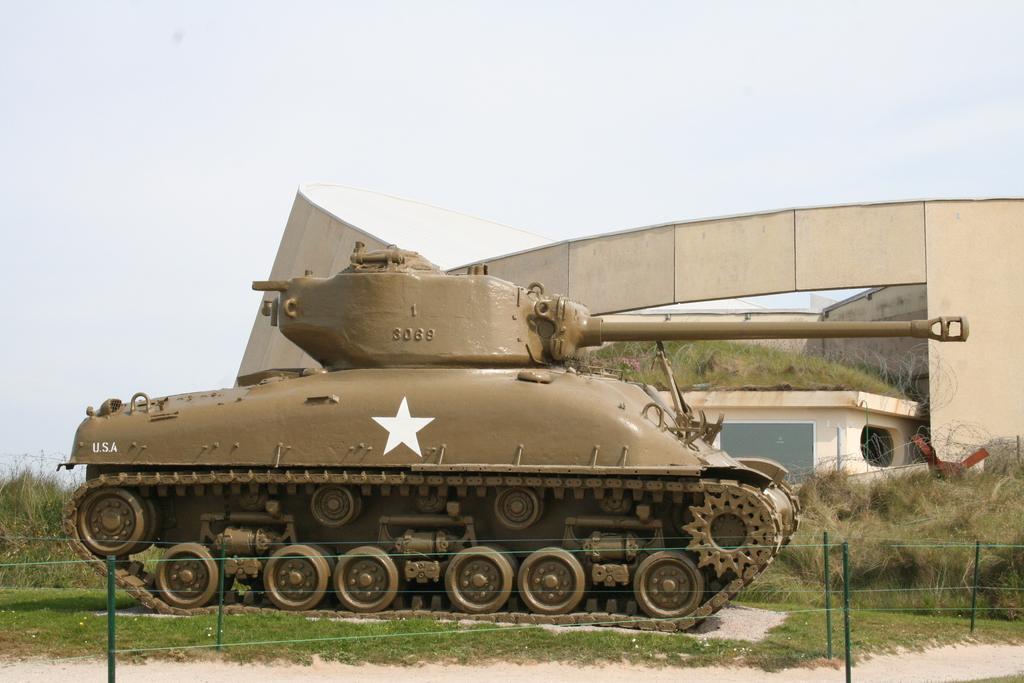What is the main object on the surface in the image? There is a tank on the surface in the image. What type of vegetation can be seen in the image? There is grass visible in the image, as well as plants. What structures are present in the image? There are poles and a house in the image. What else can be seen in the image besides the main objects? There are objects in the image. What is visible in the background of the image? The sky is visible in the background of the image. Where is the hydrant located in the image? There is no hydrant present in the image. What type of fruit is hanging from the plants in the image? There is no fruit mentioned in the image, only plants. What type of sail can be seen in the image? There is no sail present in the image. 